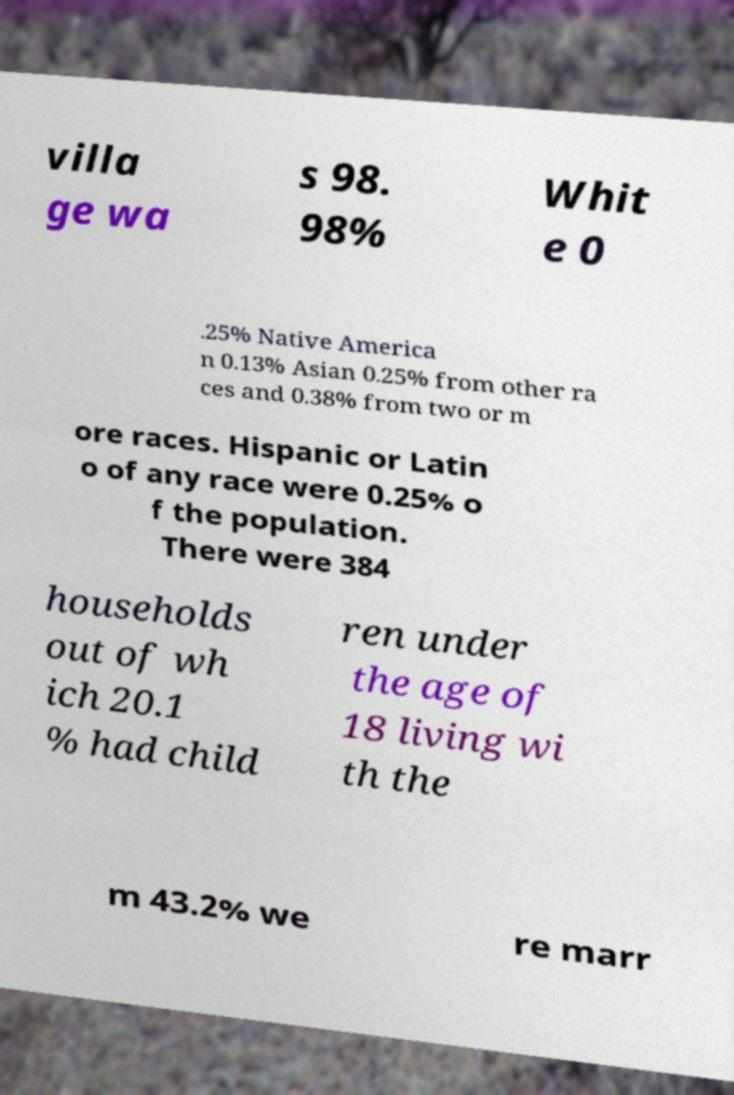I need the written content from this picture converted into text. Can you do that? villa ge wa s 98. 98% Whit e 0 .25% Native America n 0.13% Asian 0.25% from other ra ces and 0.38% from two or m ore races. Hispanic or Latin o of any race were 0.25% o f the population. There were 384 households out of wh ich 20.1 % had child ren under the age of 18 living wi th the m 43.2% we re marr 